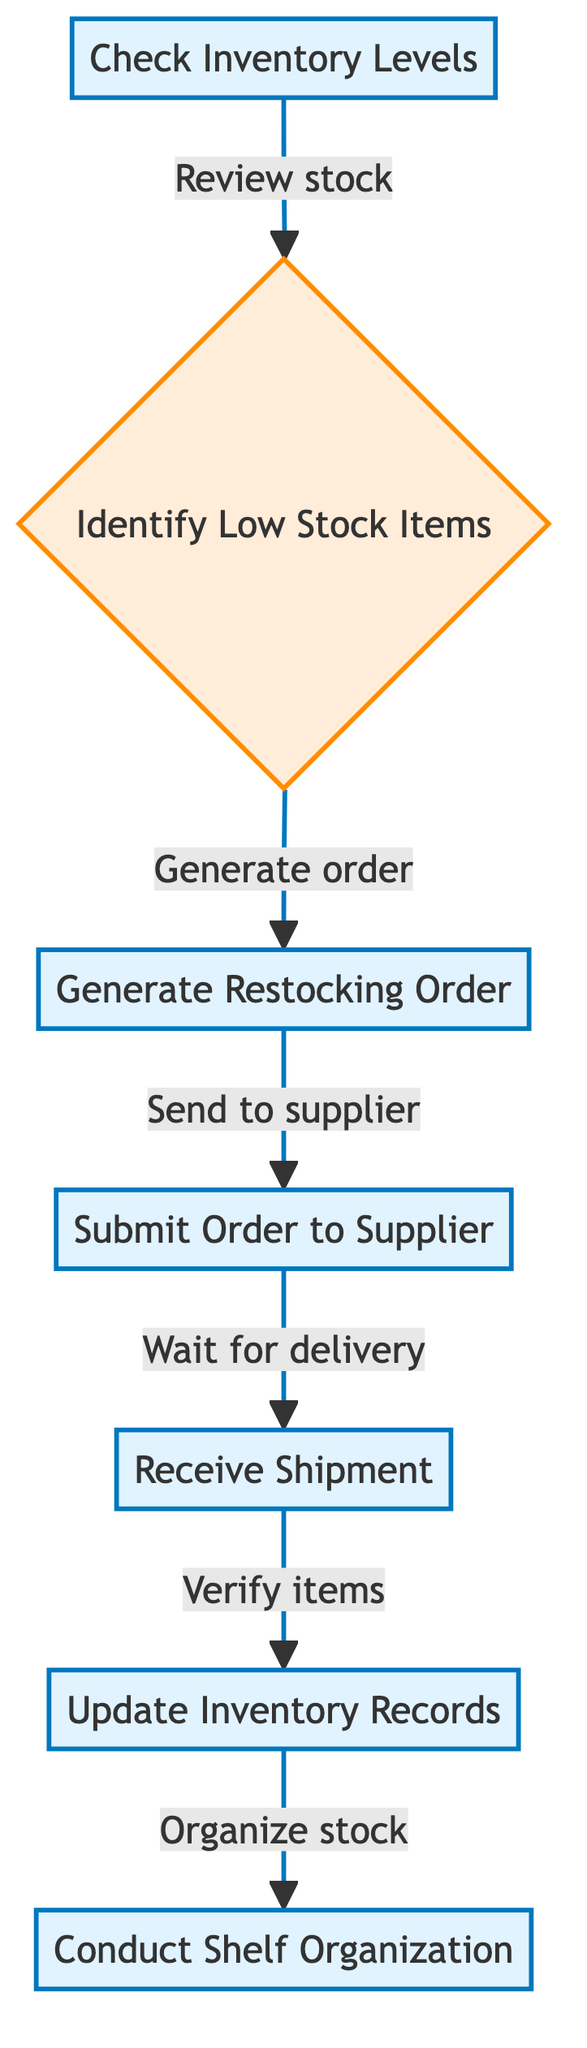What is the first step in the inventory restocking workflow? The first step detailed in the diagram is "Check Inventory Levels." This was identified by starting from the beginning node (A) and observing that it leads the workflow.
Answer: Check Inventory Levels How many total steps are there in the inventory restocking workflow? By counting each step represented in the diagram, there are seven distinct nodes that describe the processes involved in the workflow.
Answer: 7 What is the relationship between "Receive Shipment" and "Update Inventory Records"? The diagram indicates that after "Receive Shipment," which is node E, the next step is "Update Inventory Records," which is node F. This shows a direct sequenced relationship between these two steps in the workflow.
Answer: Submit Order to Supplier Which action follows identifying low stock items in the workflow? After identifying low stock items, as depicted in the diagram, the next action is "Generate Restocking Order." This can be confirmed by traversing from node B to node C.
Answer: Generate Restocking Order What are the last two actions in the inventory restocking workflow? The last two actions in sequence are "Update Inventory Records" and "Conduct Shelf Organization," observed by checking the flow from F to G.
Answer: Update Inventory Records, Conduct Shelf Organization Is there any decision node in the inventory restocking workflow? Yes, there is a decision node, which is "Identify Low Stock Items." This is noted as it has a branching relationship in the flow indicating a decision-making process is involved.
Answer: Identify Low Stock Items What step is involved in verifying the delivered items? The step that includes verifying the delivered items is "Receive Shipment," as indicated by node E in the diagram flowing to checking against the order.
Answer: Receive Shipment What is the purpose of the "Conduct Shelf Organization" step? The purpose of "Conduct Shelf Organization" is to arrange the newly received items on shelves for visibility and access, as described in the diagram's explanation for node G.
Answer: Arrange newly received items on shelves 